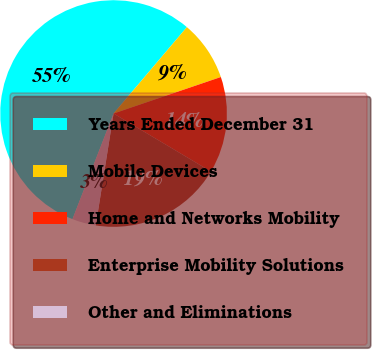<chart> <loc_0><loc_0><loc_500><loc_500><pie_chart><fcel>Years Ended December 31<fcel>Mobile Devices<fcel>Home and Networks Mobility<fcel>Enterprise Mobility Solutions<fcel>Other and Eliminations<nl><fcel>55.29%<fcel>8.58%<fcel>13.77%<fcel>18.96%<fcel>3.39%<nl></chart> 